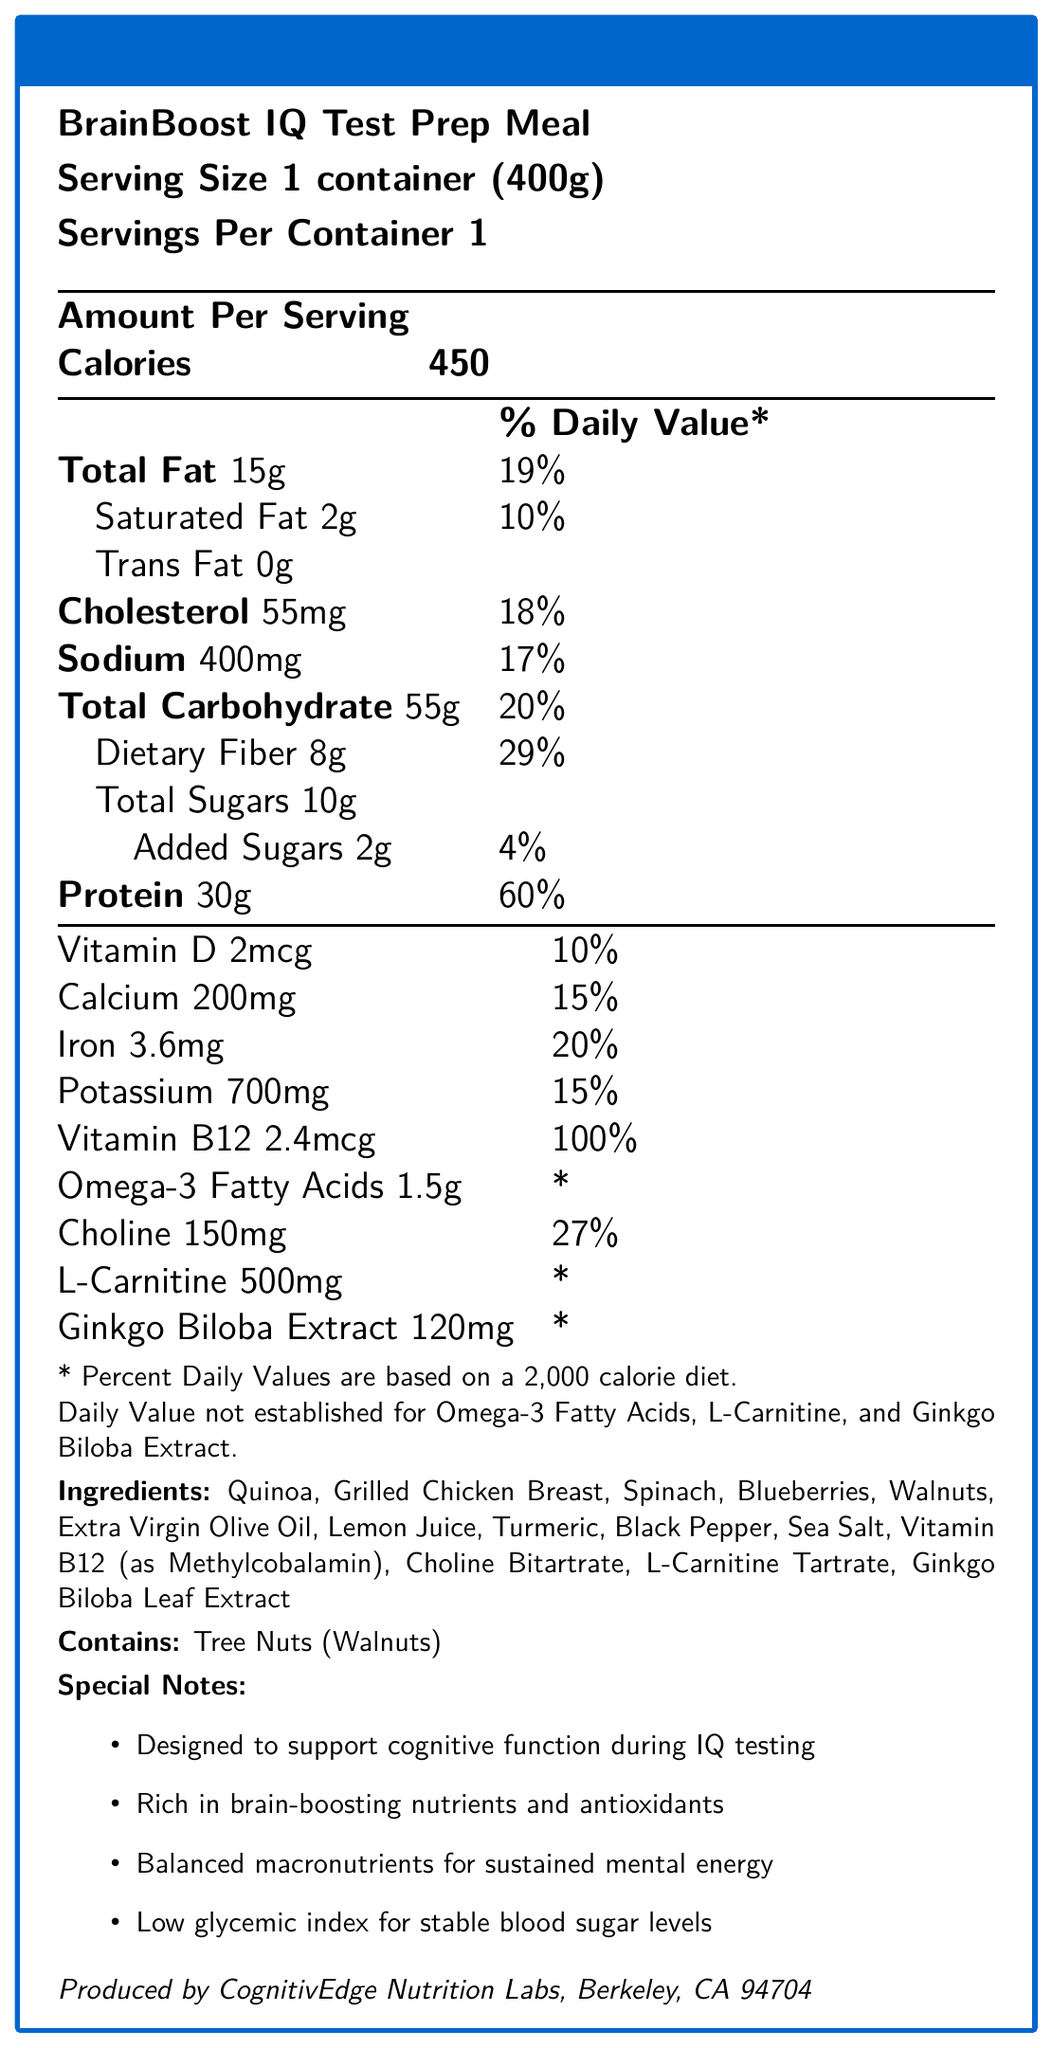what is the name of the product? The name of the product is listed at the top as "BrainBoost IQ Test Prep Meal".
Answer: BrainBoost IQ Test Prep Meal what is the serving size of the meal? The serving size is explicitly mentioned as "1 container (400g)".
Answer: 1 container (400g) how many calories does a serving of this meal contain? The document states that the amount per serving is 450 calories under the "Amount Per Serving" section.
Answer: 450 calories what percentage of the daily value of protein does this meal provide? The nutrition facts table indicates that the protein content is 30g, which is 60% of the daily value.
Answer: 60% which ingredient in the meal might cause allergies? The allergen information mentions "Contains: Tree Nuts (Walnuts)".
Answer: Walnuts how much dietary fiber is in the meal? A. 5g B. 8g C. 10g D. 12g The document lists the amount of dietary fiber as 8g.
Answer: B which nutrient has the highest daily value percentage in this meal? I. Vitamin D II. Vitamin B12 III. Calcium IV. Iron Vitamin B12 has a daily value percentage of 100%, which is the highest among the listed nutrients.
Answer: II. Vitamin B12 does the meal contain any trans fat? The nutrition facts show that the trans fat content is 0g.
Answer: No does this meal support cognitive function? One of the special notes states that the meal is designed to support cognitive function during IQ testing.
Answer: Yes summarize the purpose and key features of this meal. The main idea of the document is to provide detailed nutritional information about the BrainBoost IQ Test Prep Meal, emphasizing its cognitive benefits and balanced nutritional profile.
Answer: The BrainBoost IQ Test Prep Meal is designed to enhance cognitive performance during IQ testing. It contains balanced macronutrients, brain-boosting nutrients, and antioxidants. It is a 400g meal with 450 calories, rich in protein (30g), dietary fiber (8g), and includes special ingredients like Vitamin B12, Choline, and Ginkgo Biloba Extract. It also has a low glycemic index for stable blood sugar levels. how much sodium does one serving of this meal contain? The nutrition facts table lists the sodium content per serving as 400mg.
Answer: 400mg what is one key ingredient mentioned designed specifically to boost brain function? Ginkgo Biloba Extract is known for its cognitive benefits and is one of the ingredients listed in the document.
Answer: Ginkgo Biloba Extract what is the combined total percentage of daily value for cholesterol and sodium in this meal? The daily values for cholesterol and sodium are 18% and 17% respectively, which sum up to 35%.
Answer: 35% what is the source of Vitamin B12 in the meal? The ingredient list specifies that Vitamin B12 is provided as Methylcobalamin.
Answer: Methylcobalamin how much calcium is in the meal? The nutrition facts table lists the calcium content per serving as 200mg.
Answer: 200mg is the exact amount of omega-3 fatty acids established based on the daily value? The document states that omega-3 fatty acids have a note: "Daily Value not established".
Answer: No how many servings are there in one container? The document specifies that each container has 1 serving.
Answer: 1 where is this meal produced? The manufacturer information at the end of the document states the location as Berkeley, CA 94704.
Answer: Berkeley, CA 94704 what is the glycemic index of the meal? The document mentions that the meal has a low glycemic index but does not provide a specific value.
Answer: Cannot be determined 